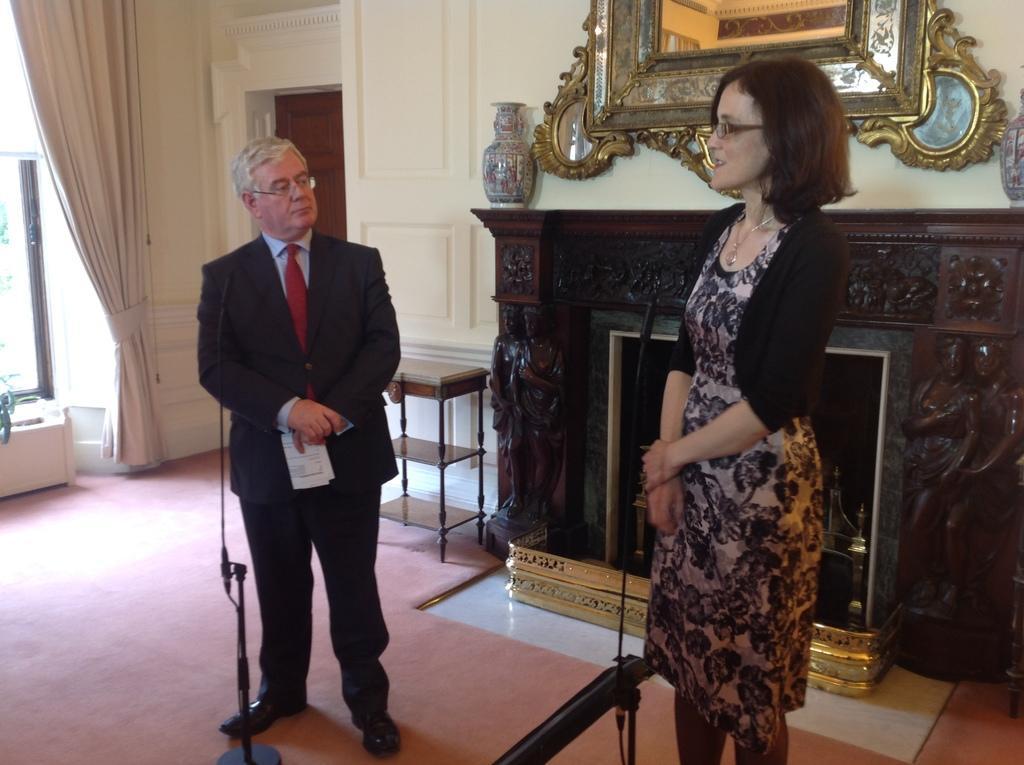Could you give a brief overview of what you see in this image? Here I can see a man and a woman are standing. The woman is speaking by looking at the left side. The man is looking at her and he is holding a paper in the hand. At the back of these people there are two tables. In the background there is a door to the wall. On the left side there is a curtain and a metal stand. At the top of the image there is a mirror which is attached to the wall. In front of this woman there is a metal object placed on the floor. 